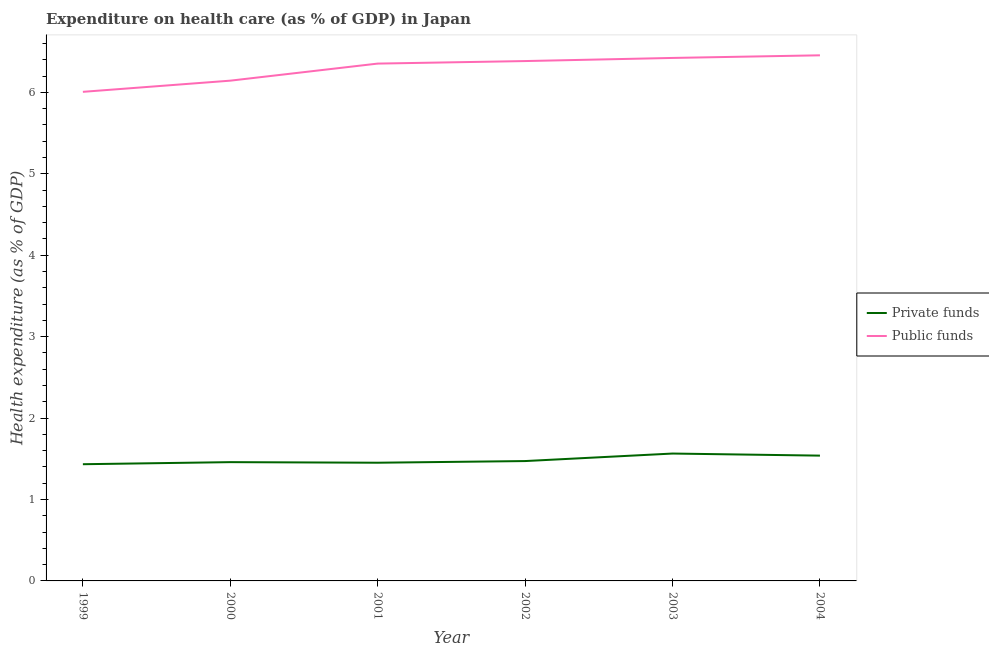Is the number of lines equal to the number of legend labels?
Your answer should be very brief. Yes. What is the amount of private funds spent in healthcare in 2000?
Make the answer very short. 1.46. Across all years, what is the maximum amount of private funds spent in healthcare?
Ensure brevity in your answer.  1.56. Across all years, what is the minimum amount of private funds spent in healthcare?
Offer a very short reply. 1.43. In which year was the amount of public funds spent in healthcare maximum?
Keep it short and to the point. 2004. What is the total amount of private funds spent in healthcare in the graph?
Provide a succinct answer. 8.92. What is the difference between the amount of public funds spent in healthcare in 1999 and that in 2004?
Ensure brevity in your answer.  -0.45. What is the difference between the amount of public funds spent in healthcare in 2004 and the amount of private funds spent in healthcare in 2000?
Your answer should be very brief. 5. What is the average amount of public funds spent in healthcare per year?
Your answer should be compact. 6.3. In the year 2004, what is the difference between the amount of public funds spent in healthcare and amount of private funds spent in healthcare?
Your response must be concise. 4.92. In how many years, is the amount of private funds spent in healthcare greater than 4.4 %?
Offer a terse response. 0. What is the ratio of the amount of public funds spent in healthcare in 1999 to that in 2003?
Keep it short and to the point. 0.94. Is the difference between the amount of private funds spent in healthcare in 2001 and 2004 greater than the difference between the amount of public funds spent in healthcare in 2001 and 2004?
Offer a very short reply. Yes. What is the difference between the highest and the second highest amount of public funds spent in healthcare?
Provide a short and direct response. 0.03. What is the difference between the highest and the lowest amount of public funds spent in healthcare?
Your answer should be very brief. 0.45. How many lines are there?
Your answer should be very brief. 2. Does the graph contain grids?
Ensure brevity in your answer.  No. How many legend labels are there?
Offer a very short reply. 2. How are the legend labels stacked?
Provide a short and direct response. Vertical. What is the title of the graph?
Your answer should be compact. Expenditure on health care (as % of GDP) in Japan. Does "Constant 2005 US$" appear as one of the legend labels in the graph?
Your response must be concise. No. What is the label or title of the X-axis?
Offer a very short reply. Year. What is the label or title of the Y-axis?
Offer a terse response. Health expenditure (as % of GDP). What is the Health expenditure (as % of GDP) in Private funds in 1999?
Make the answer very short. 1.43. What is the Health expenditure (as % of GDP) in Public funds in 1999?
Your answer should be very brief. 6.01. What is the Health expenditure (as % of GDP) of Private funds in 2000?
Give a very brief answer. 1.46. What is the Health expenditure (as % of GDP) of Public funds in 2000?
Provide a succinct answer. 6.14. What is the Health expenditure (as % of GDP) of Private funds in 2001?
Provide a succinct answer. 1.45. What is the Health expenditure (as % of GDP) of Public funds in 2001?
Keep it short and to the point. 6.35. What is the Health expenditure (as % of GDP) of Private funds in 2002?
Make the answer very short. 1.47. What is the Health expenditure (as % of GDP) of Public funds in 2002?
Give a very brief answer. 6.39. What is the Health expenditure (as % of GDP) of Private funds in 2003?
Give a very brief answer. 1.56. What is the Health expenditure (as % of GDP) in Public funds in 2003?
Your answer should be compact. 6.42. What is the Health expenditure (as % of GDP) of Private funds in 2004?
Your answer should be compact. 1.54. What is the Health expenditure (as % of GDP) in Public funds in 2004?
Ensure brevity in your answer.  6.46. Across all years, what is the maximum Health expenditure (as % of GDP) in Private funds?
Your answer should be very brief. 1.56. Across all years, what is the maximum Health expenditure (as % of GDP) of Public funds?
Offer a very short reply. 6.46. Across all years, what is the minimum Health expenditure (as % of GDP) of Private funds?
Your answer should be very brief. 1.43. Across all years, what is the minimum Health expenditure (as % of GDP) of Public funds?
Keep it short and to the point. 6.01. What is the total Health expenditure (as % of GDP) in Private funds in the graph?
Offer a very short reply. 8.92. What is the total Health expenditure (as % of GDP) of Public funds in the graph?
Make the answer very short. 37.77. What is the difference between the Health expenditure (as % of GDP) in Private funds in 1999 and that in 2000?
Your answer should be very brief. -0.03. What is the difference between the Health expenditure (as % of GDP) of Public funds in 1999 and that in 2000?
Provide a short and direct response. -0.14. What is the difference between the Health expenditure (as % of GDP) of Private funds in 1999 and that in 2001?
Ensure brevity in your answer.  -0.02. What is the difference between the Health expenditure (as % of GDP) in Public funds in 1999 and that in 2001?
Offer a terse response. -0.35. What is the difference between the Health expenditure (as % of GDP) of Private funds in 1999 and that in 2002?
Keep it short and to the point. -0.04. What is the difference between the Health expenditure (as % of GDP) in Public funds in 1999 and that in 2002?
Your answer should be very brief. -0.38. What is the difference between the Health expenditure (as % of GDP) in Private funds in 1999 and that in 2003?
Offer a very short reply. -0.13. What is the difference between the Health expenditure (as % of GDP) in Public funds in 1999 and that in 2003?
Your answer should be compact. -0.42. What is the difference between the Health expenditure (as % of GDP) of Private funds in 1999 and that in 2004?
Ensure brevity in your answer.  -0.11. What is the difference between the Health expenditure (as % of GDP) in Public funds in 1999 and that in 2004?
Your answer should be very brief. -0.45. What is the difference between the Health expenditure (as % of GDP) in Private funds in 2000 and that in 2001?
Provide a succinct answer. 0.01. What is the difference between the Health expenditure (as % of GDP) in Public funds in 2000 and that in 2001?
Provide a succinct answer. -0.21. What is the difference between the Health expenditure (as % of GDP) in Private funds in 2000 and that in 2002?
Your answer should be very brief. -0.01. What is the difference between the Health expenditure (as % of GDP) of Public funds in 2000 and that in 2002?
Offer a terse response. -0.24. What is the difference between the Health expenditure (as % of GDP) in Private funds in 2000 and that in 2003?
Ensure brevity in your answer.  -0.11. What is the difference between the Health expenditure (as % of GDP) in Public funds in 2000 and that in 2003?
Ensure brevity in your answer.  -0.28. What is the difference between the Health expenditure (as % of GDP) in Private funds in 2000 and that in 2004?
Provide a short and direct response. -0.08. What is the difference between the Health expenditure (as % of GDP) of Public funds in 2000 and that in 2004?
Your response must be concise. -0.31. What is the difference between the Health expenditure (as % of GDP) of Private funds in 2001 and that in 2002?
Your response must be concise. -0.02. What is the difference between the Health expenditure (as % of GDP) in Public funds in 2001 and that in 2002?
Keep it short and to the point. -0.03. What is the difference between the Health expenditure (as % of GDP) of Private funds in 2001 and that in 2003?
Offer a terse response. -0.11. What is the difference between the Health expenditure (as % of GDP) of Public funds in 2001 and that in 2003?
Offer a terse response. -0.07. What is the difference between the Health expenditure (as % of GDP) of Private funds in 2001 and that in 2004?
Keep it short and to the point. -0.09. What is the difference between the Health expenditure (as % of GDP) in Public funds in 2001 and that in 2004?
Provide a short and direct response. -0.1. What is the difference between the Health expenditure (as % of GDP) of Private funds in 2002 and that in 2003?
Offer a very short reply. -0.09. What is the difference between the Health expenditure (as % of GDP) in Public funds in 2002 and that in 2003?
Offer a very short reply. -0.04. What is the difference between the Health expenditure (as % of GDP) in Private funds in 2002 and that in 2004?
Ensure brevity in your answer.  -0.07. What is the difference between the Health expenditure (as % of GDP) in Public funds in 2002 and that in 2004?
Offer a terse response. -0.07. What is the difference between the Health expenditure (as % of GDP) of Private funds in 2003 and that in 2004?
Your response must be concise. 0.03. What is the difference between the Health expenditure (as % of GDP) in Public funds in 2003 and that in 2004?
Your answer should be very brief. -0.03. What is the difference between the Health expenditure (as % of GDP) of Private funds in 1999 and the Health expenditure (as % of GDP) of Public funds in 2000?
Your answer should be very brief. -4.71. What is the difference between the Health expenditure (as % of GDP) in Private funds in 1999 and the Health expenditure (as % of GDP) in Public funds in 2001?
Ensure brevity in your answer.  -4.92. What is the difference between the Health expenditure (as % of GDP) of Private funds in 1999 and the Health expenditure (as % of GDP) of Public funds in 2002?
Offer a terse response. -4.95. What is the difference between the Health expenditure (as % of GDP) in Private funds in 1999 and the Health expenditure (as % of GDP) in Public funds in 2003?
Provide a short and direct response. -4.99. What is the difference between the Health expenditure (as % of GDP) of Private funds in 1999 and the Health expenditure (as % of GDP) of Public funds in 2004?
Your response must be concise. -5.02. What is the difference between the Health expenditure (as % of GDP) of Private funds in 2000 and the Health expenditure (as % of GDP) of Public funds in 2001?
Your answer should be very brief. -4.9. What is the difference between the Health expenditure (as % of GDP) of Private funds in 2000 and the Health expenditure (as % of GDP) of Public funds in 2002?
Give a very brief answer. -4.93. What is the difference between the Health expenditure (as % of GDP) of Private funds in 2000 and the Health expenditure (as % of GDP) of Public funds in 2003?
Your answer should be compact. -4.96. What is the difference between the Health expenditure (as % of GDP) of Private funds in 2000 and the Health expenditure (as % of GDP) of Public funds in 2004?
Your answer should be very brief. -5. What is the difference between the Health expenditure (as % of GDP) in Private funds in 2001 and the Health expenditure (as % of GDP) in Public funds in 2002?
Give a very brief answer. -4.93. What is the difference between the Health expenditure (as % of GDP) in Private funds in 2001 and the Health expenditure (as % of GDP) in Public funds in 2003?
Make the answer very short. -4.97. What is the difference between the Health expenditure (as % of GDP) of Private funds in 2001 and the Health expenditure (as % of GDP) of Public funds in 2004?
Your answer should be compact. -5. What is the difference between the Health expenditure (as % of GDP) of Private funds in 2002 and the Health expenditure (as % of GDP) of Public funds in 2003?
Provide a succinct answer. -4.95. What is the difference between the Health expenditure (as % of GDP) of Private funds in 2002 and the Health expenditure (as % of GDP) of Public funds in 2004?
Your response must be concise. -4.98. What is the difference between the Health expenditure (as % of GDP) in Private funds in 2003 and the Health expenditure (as % of GDP) in Public funds in 2004?
Keep it short and to the point. -4.89. What is the average Health expenditure (as % of GDP) of Private funds per year?
Your answer should be very brief. 1.49. What is the average Health expenditure (as % of GDP) in Public funds per year?
Keep it short and to the point. 6.3. In the year 1999, what is the difference between the Health expenditure (as % of GDP) in Private funds and Health expenditure (as % of GDP) in Public funds?
Offer a terse response. -4.57. In the year 2000, what is the difference between the Health expenditure (as % of GDP) of Private funds and Health expenditure (as % of GDP) of Public funds?
Provide a short and direct response. -4.69. In the year 2001, what is the difference between the Health expenditure (as % of GDP) in Private funds and Health expenditure (as % of GDP) in Public funds?
Provide a succinct answer. -4.9. In the year 2002, what is the difference between the Health expenditure (as % of GDP) in Private funds and Health expenditure (as % of GDP) in Public funds?
Ensure brevity in your answer.  -4.91. In the year 2003, what is the difference between the Health expenditure (as % of GDP) in Private funds and Health expenditure (as % of GDP) in Public funds?
Offer a very short reply. -4.86. In the year 2004, what is the difference between the Health expenditure (as % of GDP) in Private funds and Health expenditure (as % of GDP) in Public funds?
Ensure brevity in your answer.  -4.92. What is the ratio of the Health expenditure (as % of GDP) of Private funds in 1999 to that in 2000?
Make the answer very short. 0.98. What is the ratio of the Health expenditure (as % of GDP) in Public funds in 1999 to that in 2000?
Keep it short and to the point. 0.98. What is the ratio of the Health expenditure (as % of GDP) in Private funds in 1999 to that in 2001?
Make the answer very short. 0.99. What is the ratio of the Health expenditure (as % of GDP) of Public funds in 1999 to that in 2001?
Keep it short and to the point. 0.95. What is the ratio of the Health expenditure (as % of GDP) of Private funds in 1999 to that in 2002?
Ensure brevity in your answer.  0.97. What is the ratio of the Health expenditure (as % of GDP) in Public funds in 1999 to that in 2002?
Make the answer very short. 0.94. What is the ratio of the Health expenditure (as % of GDP) in Private funds in 1999 to that in 2003?
Your answer should be very brief. 0.92. What is the ratio of the Health expenditure (as % of GDP) of Public funds in 1999 to that in 2003?
Ensure brevity in your answer.  0.94. What is the ratio of the Health expenditure (as % of GDP) of Private funds in 1999 to that in 2004?
Offer a terse response. 0.93. What is the ratio of the Health expenditure (as % of GDP) of Public funds in 1999 to that in 2004?
Ensure brevity in your answer.  0.93. What is the ratio of the Health expenditure (as % of GDP) in Private funds in 2000 to that in 2001?
Offer a terse response. 1. What is the ratio of the Health expenditure (as % of GDP) in Public funds in 2000 to that in 2001?
Provide a short and direct response. 0.97. What is the ratio of the Health expenditure (as % of GDP) of Private funds in 2000 to that in 2002?
Your answer should be very brief. 0.99. What is the ratio of the Health expenditure (as % of GDP) of Public funds in 2000 to that in 2002?
Provide a succinct answer. 0.96. What is the ratio of the Health expenditure (as % of GDP) of Private funds in 2000 to that in 2003?
Your answer should be compact. 0.93. What is the ratio of the Health expenditure (as % of GDP) of Public funds in 2000 to that in 2003?
Give a very brief answer. 0.96. What is the ratio of the Health expenditure (as % of GDP) of Private funds in 2000 to that in 2004?
Provide a succinct answer. 0.95. What is the ratio of the Health expenditure (as % of GDP) of Public funds in 2000 to that in 2004?
Make the answer very short. 0.95. What is the ratio of the Health expenditure (as % of GDP) in Private funds in 2001 to that in 2002?
Provide a short and direct response. 0.99. What is the ratio of the Health expenditure (as % of GDP) in Private funds in 2001 to that in 2003?
Give a very brief answer. 0.93. What is the ratio of the Health expenditure (as % of GDP) of Private funds in 2001 to that in 2004?
Your answer should be compact. 0.94. What is the ratio of the Health expenditure (as % of GDP) in Public funds in 2001 to that in 2004?
Keep it short and to the point. 0.98. What is the ratio of the Health expenditure (as % of GDP) in Private funds in 2002 to that in 2003?
Your answer should be compact. 0.94. What is the ratio of the Health expenditure (as % of GDP) in Public funds in 2002 to that in 2003?
Give a very brief answer. 0.99. What is the ratio of the Health expenditure (as % of GDP) in Private funds in 2002 to that in 2004?
Give a very brief answer. 0.96. What is the ratio of the Health expenditure (as % of GDP) in Public funds in 2002 to that in 2004?
Your answer should be very brief. 0.99. What is the ratio of the Health expenditure (as % of GDP) of Private funds in 2003 to that in 2004?
Provide a short and direct response. 1.02. What is the ratio of the Health expenditure (as % of GDP) of Public funds in 2003 to that in 2004?
Provide a succinct answer. 0.99. What is the difference between the highest and the second highest Health expenditure (as % of GDP) in Private funds?
Provide a short and direct response. 0.03. What is the difference between the highest and the second highest Health expenditure (as % of GDP) in Public funds?
Offer a terse response. 0.03. What is the difference between the highest and the lowest Health expenditure (as % of GDP) in Private funds?
Offer a terse response. 0.13. What is the difference between the highest and the lowest Health expenditure (as % of GDP) in Public funds?
Your answer should be compact. 0.45. 